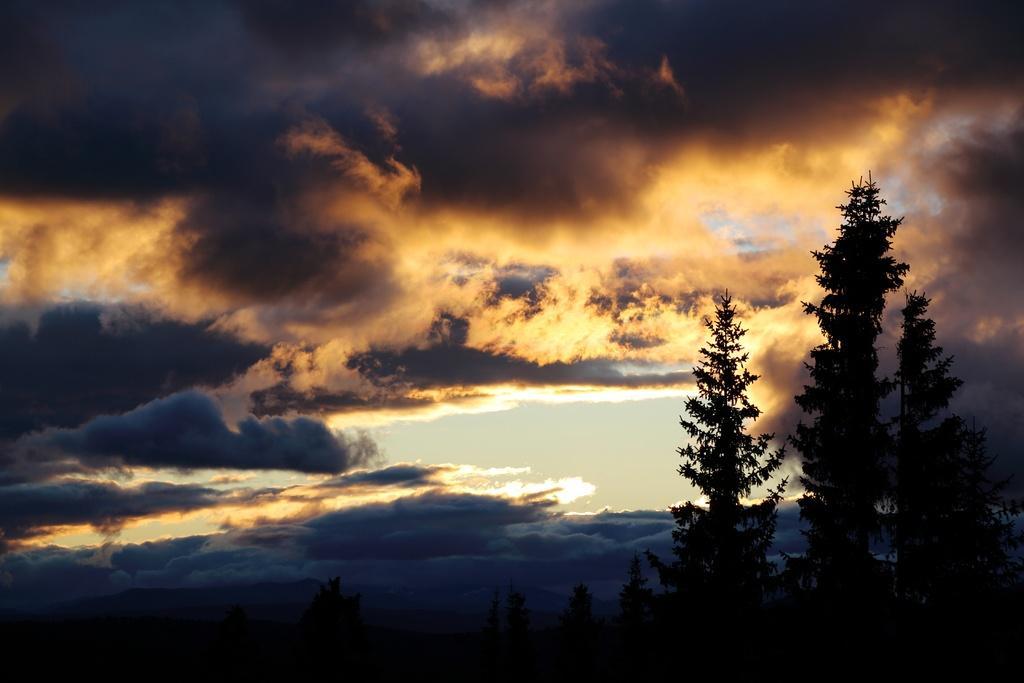How would you summarize this image in a sentence or two? In the foreground of this image, there are trees. On the top, there is the sky and the cloud. 